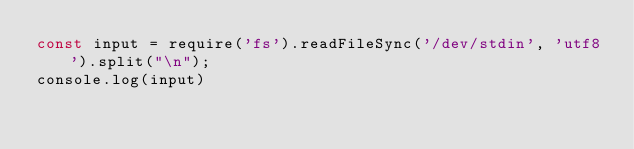Convert code to text. <code><loc_0><loc_0><loc_500><loc_500><_JavaScript_>const input = require('fs').readFileSync('/dev/stdin', 'utf8').split("\n");
console.log(input)</code> 